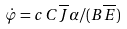Convert formula to latex. <formula><loc_0><loc_0><loc_500><loc_500>\dot { \varphi } = c \, C \overline { J } \alpha / ( B \overline { E } )</formula> 